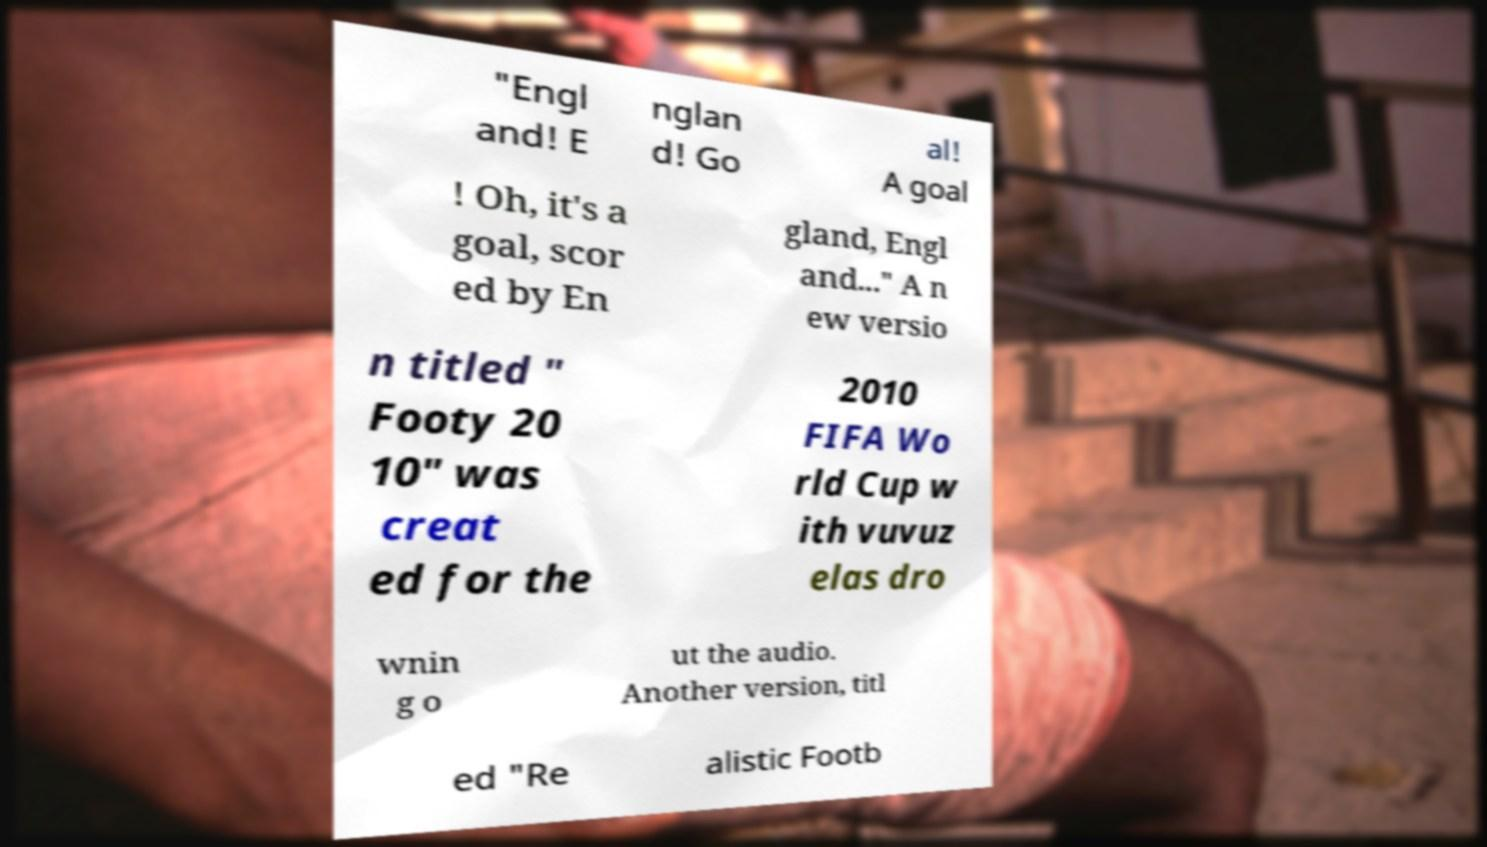I need the written content from this picture converted into text. Can you do that? "Engl and! E nglan d! Go al! A goal ! Oh, it's a goal, scor ed by En gland, Engl and..." A n ew versio n titled " Footy 20 10" was creat ed for the 2010 FIFA Wo rld Cup w ith vuvuz elas dro wnin g o ut the audio. Another version, titl ed "Re alistic Footb 